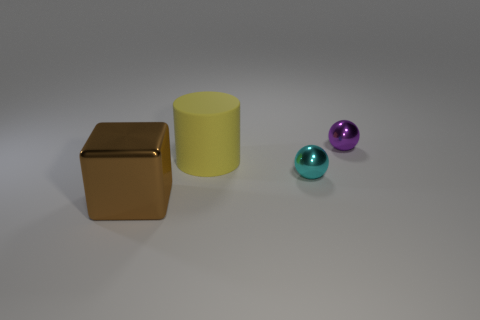There is a thing that is both on the left side of the cyan shiny thing and in front of the big yellow cylinder; what is its material?
Your answer should be compact. Metal. There is a small shiny thing behind the large yellow cylinder; is its shape the same as the large thing behind the large brown block?
Keep it short and to the point. No. Is there anything else that is made of the same material as the large cube?
Ensure brevity in your answer.  Yes. What shape is the large thing on the left side of the rubber cylinder that is on the left side of the shiny thing that is behind the big yellow rubber thing?
Your answer should be compact. Cube. What number of other objects are there of the same shape as the large brown metal object?
Make the answer very short. 0. What is the color of the matte thing that is the same size as the brown block?
Your answer should be very brief. Yellow. How many cubes are either purple metallic objects or large blue matte things?
Keep it short and to the point. 0. How many tiny balls are there?
Offer a very short reply. 2. Does the cyan shiny thing have the same shape as the metallic thing that is on the left side of the big rubber cylinder?
Offer a terse response. No. What number of things are gray metal cubes or big yellow objects?
Provide a succinct answer. 1. 